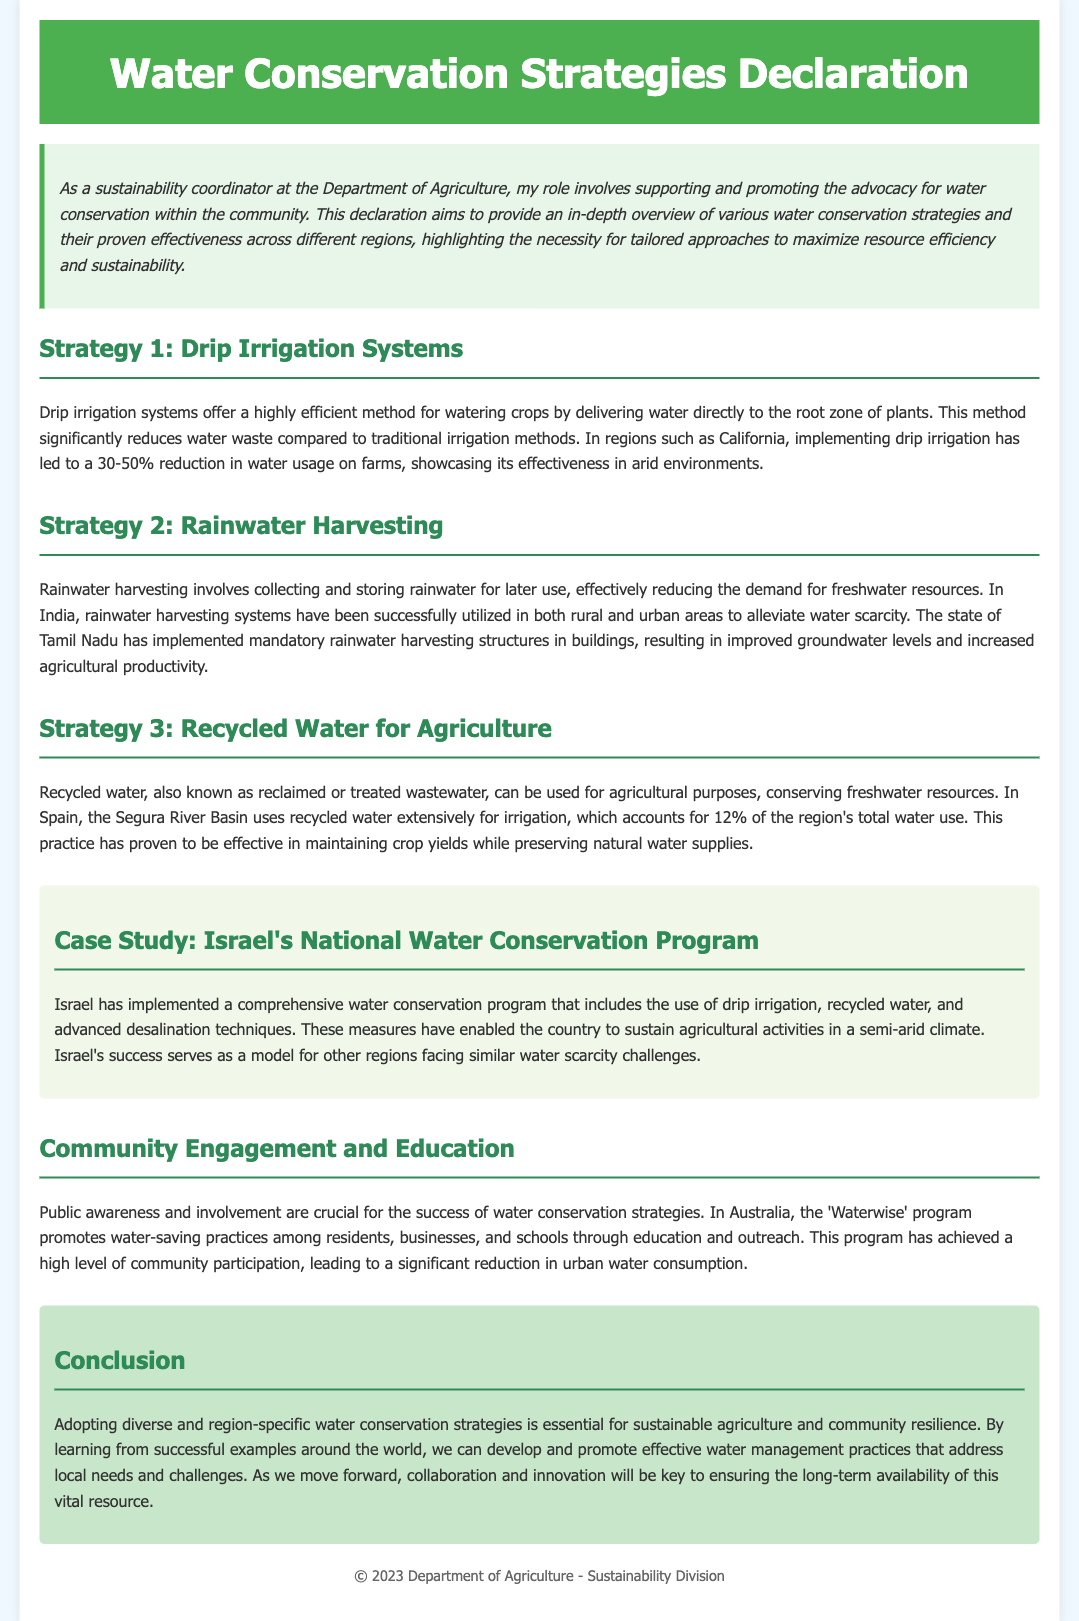what is the title of the document? The title is prominently displayed at the top of the rendered document.
Answer: Water Conservation Strategies Declaration what is the main focus of the declaration? The introduction outlines the primary objective of the declaration.
Answer: Water conservation strategies how much reduction in water usage does drip irrigation provide in California? The document specifies the percentage reduction in the context of the strategy.
Answer: 30-50% what region is known for using recycled water for irrigation? The document mentions a specific region where this practice is prevalent.
Answer: Segura River Basin which country's program serves as a model for water conservation? The case study section highlights a specific country's success in this area.
Answer: Israel what does the 'Waterwise' program focus on? This program is described in the community engagement section of the document.
Answer: Water-saving practices how much of the total water use is accounted for by recycled water in Spain? The document provides specific data regarding the use of recycled water.
Answer: 12% what is a critical factor for the success of water conservation strategies? Community engagement is emphasized throughout the document as vital for success.
Answer: Public awareness what irrigation method does the declaration promote as efficient? The declaration discusses a particular method that minimizes water waste.
Answer: Drip irrigation systems 